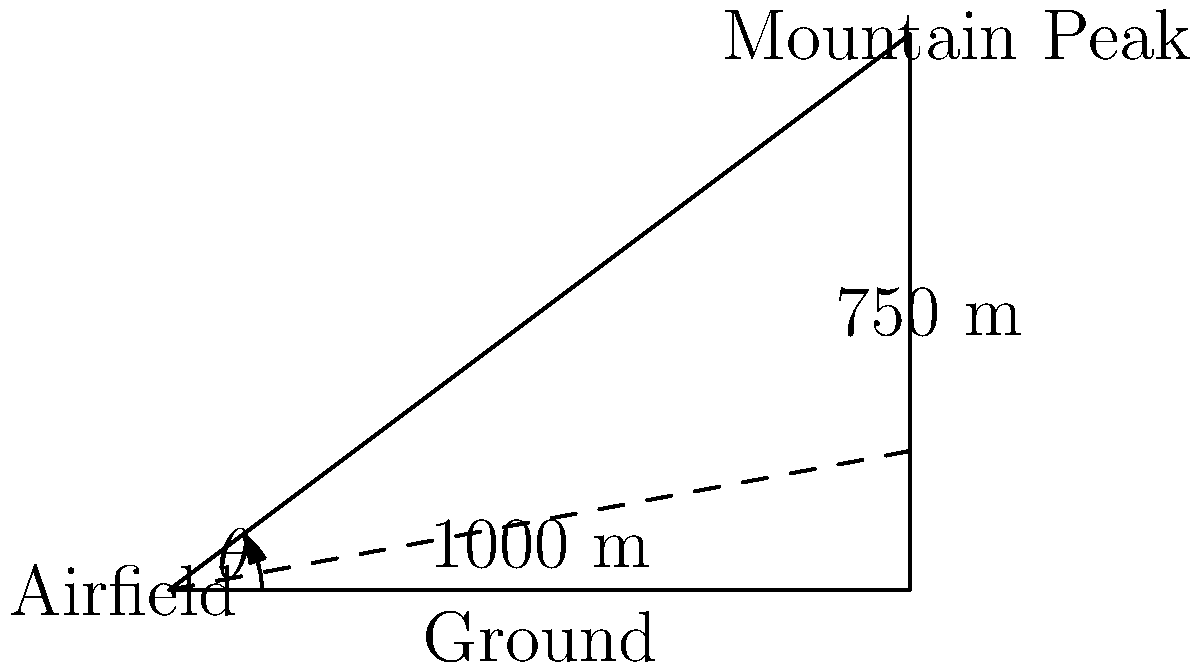A vintage photograph from a pioneering Iranian airfield shows a distant mountain peak. The photograph includes measurements indicating that the airfield is 1000 meters from the base of the mountain, and the peak is 750 meters higher than the airfield. What is the angle of elevation (θ) to the mountain peak from the airfield, rounded to the nearest degree? To find the angle of elevation, we need to use trigonometry. Let's approach this step-by-step:

1) We have a right triangle where:
   - The adjacent side (ground distance) is 1000 meters
   - The opposite side (height difference) is 750 meters

2) We need to find the angle θ, which is the angle of elevation.

3) In a right triangle, tangent of an angle is the ratio of the opposite side to the adjacent side:

   $$\tan(\theta) = \frac{\text{opposite}}{\text{adjacent}} = \frac{750}{1000}$$

4) To find θ, we need to take the inverse tangent (arctan or tan^(-1)) of this ratio:

   $$\theta = \tan^{-1}\left(\frac{750}{1000}\right)$$

5) Using a calculator or computer:

   $$\theta = \tan^{-1}(0.75) \approx 36.87\text{ degrees}$$

6) Rounding to the nearest degree:

   $$\theta \approx 37\text{ degrees}$$

Therefore, the angle of elevation from the airfield to the mountain peak is approximately 37 degrees.
Answer: 37 degrees 